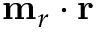<formula> <loc_0><loc_0><loc_500><loc_500>m _ { r } \cdot r</formula> 